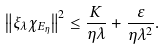Convert formula to latex. <formula><loc_0><loc_0><loc_500><loc_500>\left \| \xi _ { \lambda } \chi _ { E _ { \eta } } \right \| ^ { 2 } \leq \frac { K } { \eta \lambda } + \frac { \varepsilon } { \eta \lambda ^ { 2 } } .</formula> 